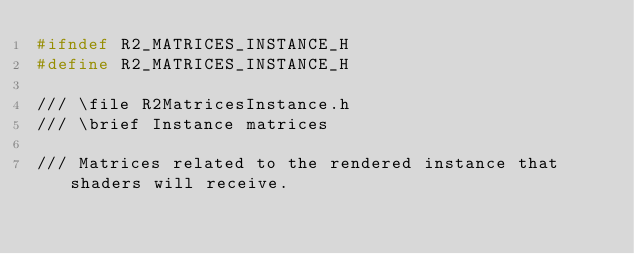Convert code to text. <code><loc_0><loc_0><loc_500><loc_500><_C_>#ifndef R2_MATRICES_INSTANCE_H
#define R2_MATRICES_INSTANCE_H

/// \file R2MatricesInstance.h
/// \brief Instance matrices

/// Matrices related to the rendered instance that shaders will receive.
</code> 